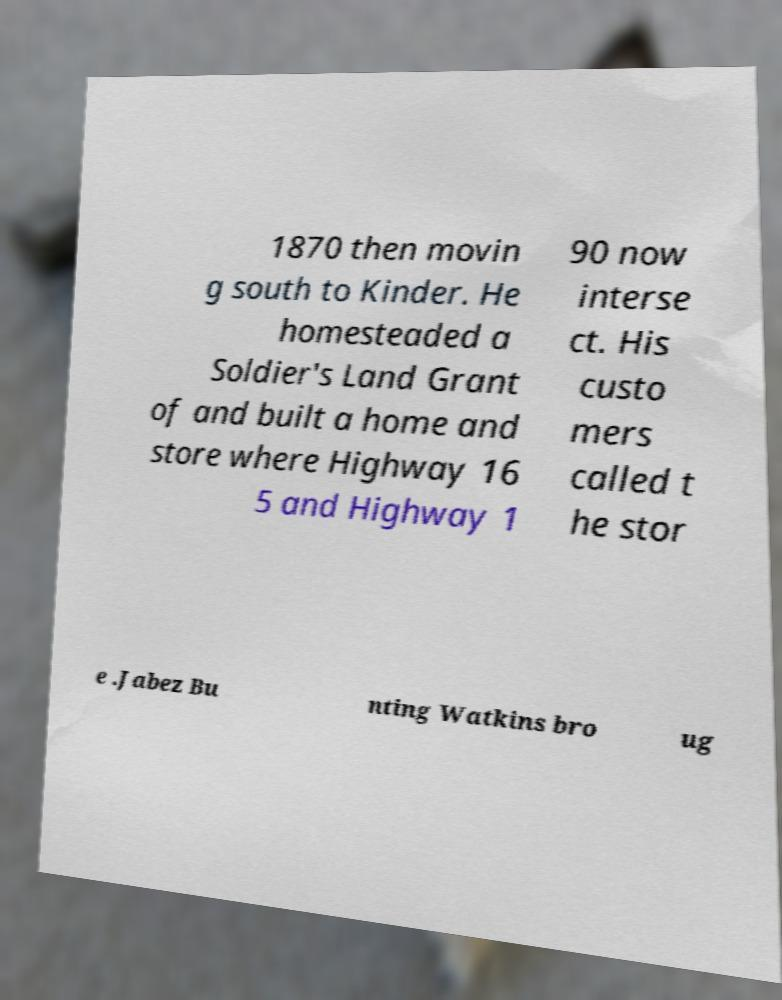Could you assist in decoding the text presented in this image and type it out clearly? 1870 then movin g south to Kinder. He homesteaded a Soldier's Land Grant of and built a home and store where Highway 16 5 and Highway 1 90 now interse ct. His custo mers called t he stor e .Jabez Bu nting Watkins bro ug 